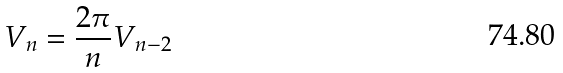Convert formula to latex. <formula><loc_0><loc_0><loc_500><loc_500>V _ { n } = \frac { 2 \pi } { n } V _ { n - 2 }</formula> 